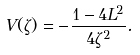<formula> <loc_0><loc_0><loc_500><loc_500>V ( \zeta ) = - \frac { 1 - 4 L ^ { 2 } } { 4 \zeta ^ { 2 } } .</formula> 